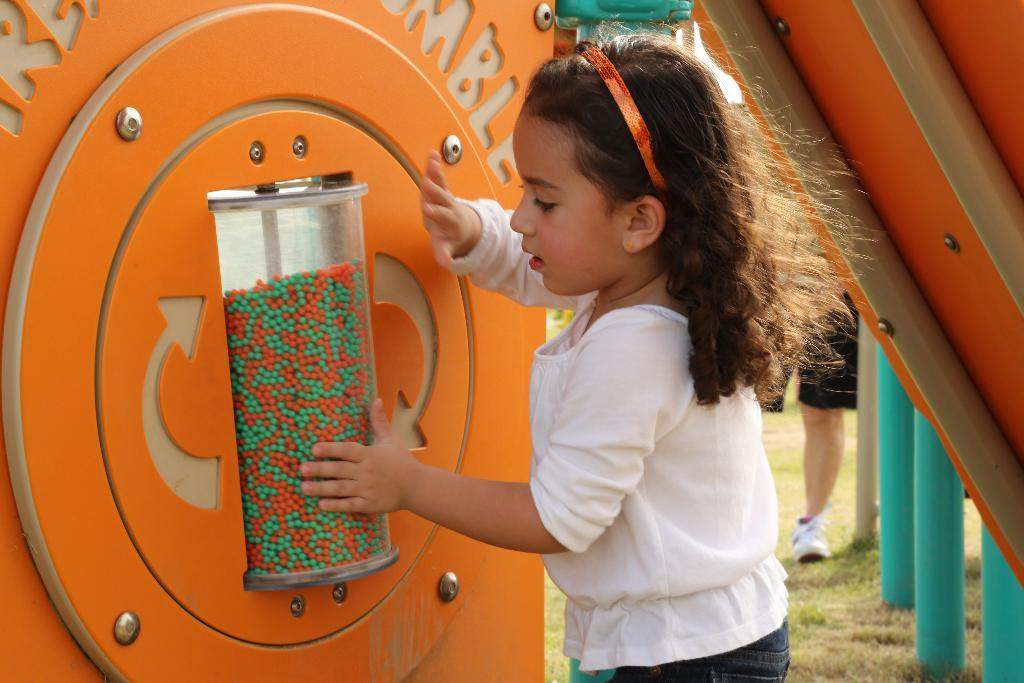Who is present in the image? There is a girl in the image. What is the girl doing in the image? The girl is touching someone playing equipment. Can you describe the person behind the girl? There are legs of a person visible behind the girl. What type of equipment can be seen in the image? There is playing equipment in the image. What type of juice is being served in the image? There is no juice present in the image. What punishment is being given to the girl in the image? There is no indication of punishment in the image; the girl is simply touching someone playing equipment. 